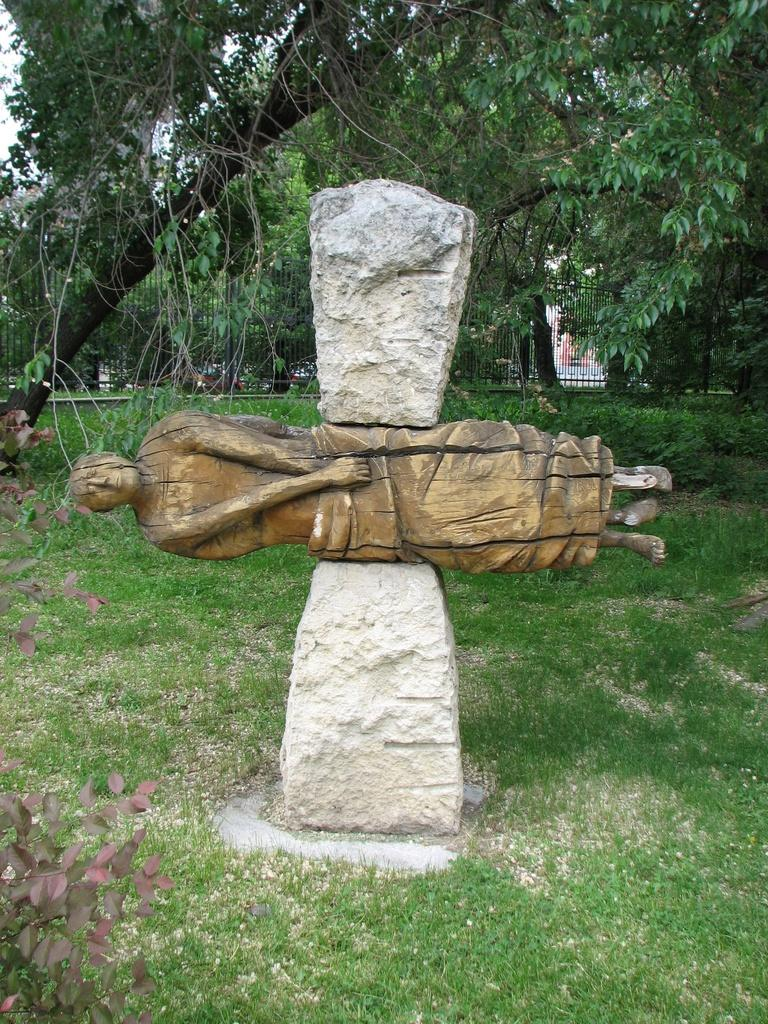What is the main subject in the image? There is a statue in the image. How is the statue positioned in relation to the stones? The statue is between two stones. What type of vegetation is present on the ground in the image? There is grass on the ground in the image. What can be seen in the background of the image? There are trees in the background of the image. What type of vegetation is on the left side of the image? There are plants on the left side of the image. What type of punishment is being administered to the statue in the image? There is no punishment being administered to the statue in the image; it is a stationary object between two stones. 